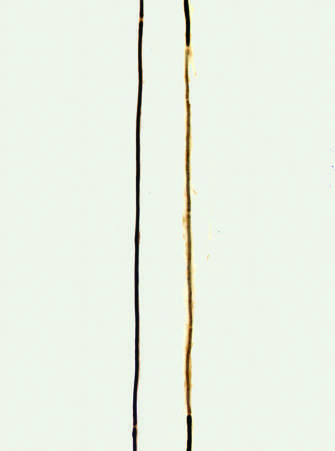what shows a segment surrounded by a series of thinly myelinated internodes of uneven length flanked on both ends by normal thicker myelin internodes?
Answer the question using a single word or phrase. The right axon 